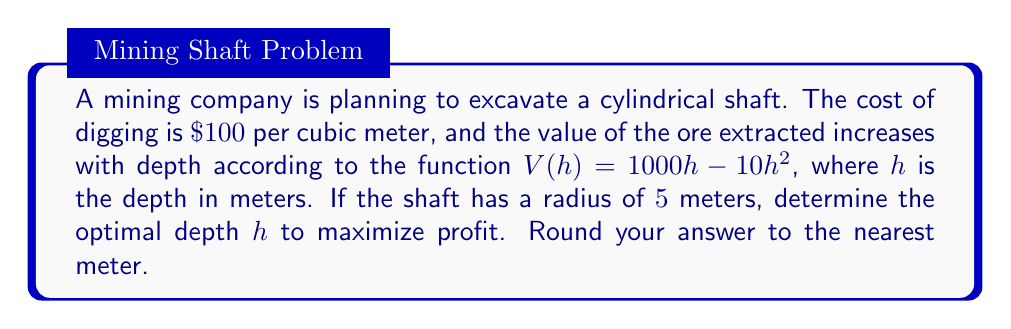Help me with this question. To solve this optimization problem, we'll follow these steps:

1) Define the profit function:
   Profit = Revenue - Cost
   $P(h) = V(h) - C(h)$

2) Revenue function is given: $V(h) = 1000h - 10h^2$

3) Cost function:
   Volume of cylinder = $\pi r^2 h$
   Cost = $100 \cdot \pi r^2 h$
   $C(h) = 100 \cdot \pi \cdot 5^2 \cdot h = 7853.98h$

4) Profit function:
   $P(h) = (1000h - 10h^2) - 7853.98h$
   $P(h) = -10h^2 - 6853.98h$

5) To find the maximum profit, we differentiate $P(h)$ and set it to zero:
   $$\frac{dP}{dh} = -20h - 6853.98 = 0$$

6) Solve for $h$:
   $-20h = 6853.98$
   $h = -342.699$

7) The negative value doesn't make sense for depth, so we consider the positive root:
   $h = 342.699$ meters

8) Rounding to the nearest meter:
   $h = 343$ meters

9) To confirm this is a maximum, we can check the second derivative:
   $$\frac{d^2P}{dh^2} = -20$$
   This is negative, confirming a maximum.
Answer: 343 meters 